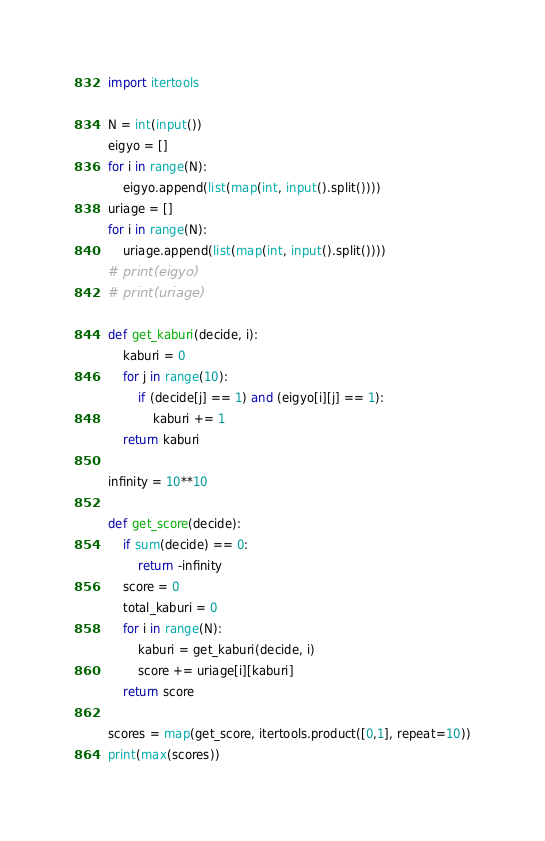<code> <loc_0><loc_0><loc_500><loc_500><_Python_>import itertools

N = int(input())
eigyo = []
for i in range(N):
    eigyo.append(list(map(int, input().split())))
uriage = []
for i in range(N):
    uriage.append(list(map(int, input().split())))
# print(eigyo)
# print(uriage)

def get_kaburi(decide, i):
    kaburi = 0
    for j in range(10):
        if (decide[j] == 1) and (eigyo[i][j] == 1):
            kaburi += 1
    return kaburi

infinity = 10**10

def get_score(decide):
    if sum(decide) == 0:
        return -infinity
    score = 0
    total_kaburi = 0
    for i in range(N):
        kaburi = get_kaburi(decide, i)
        score += uriage[i][kaburi]
    return score

scores = map(get_score, itertools.product([0,1], repeat=10))
print(max(scores))
</code> 